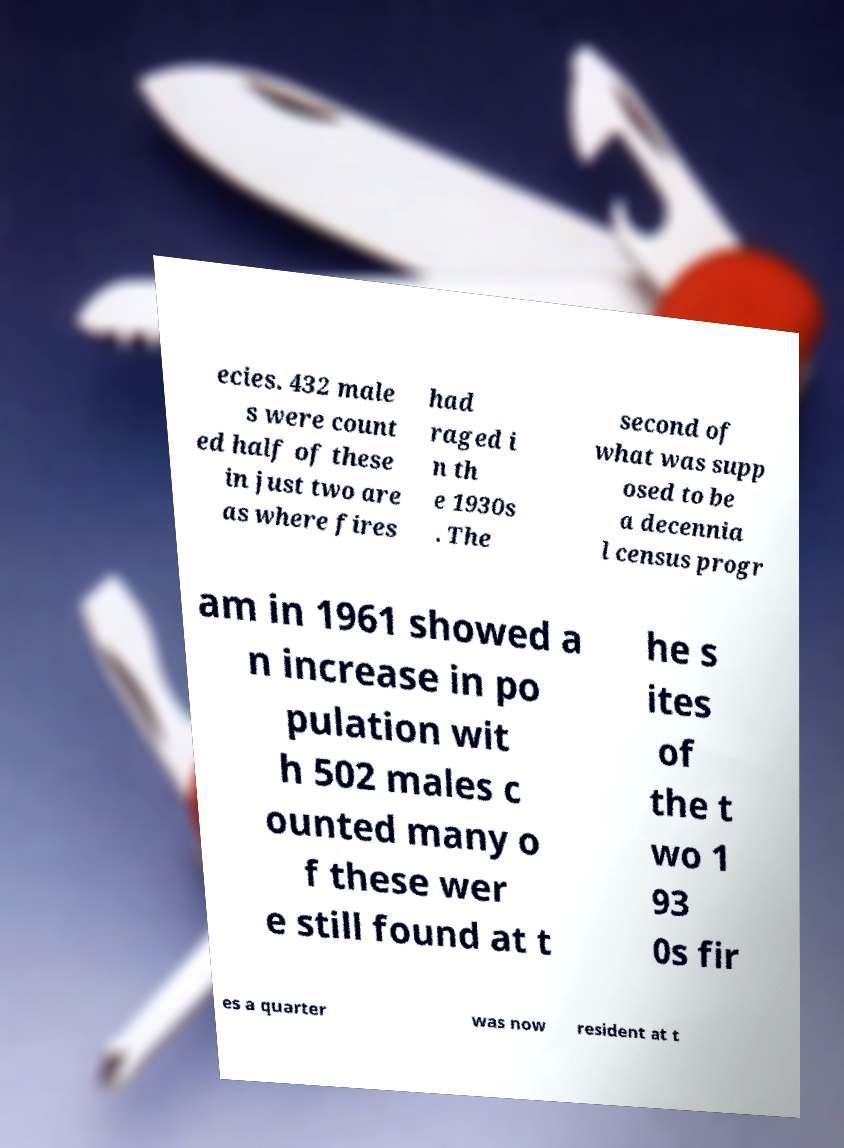Can you read and provide the text displayed in the image?This photo seems to have some interesting text. Can you extract and type it out for me? ecies. 432 male s were count ed half of these in just two are as where fires had raged i n th e 1930s . The second of what was supp osed to be a decennia l census progr am in 1961 showed a n increase in po pulation wit h 502 males c ounted many o f these wer e still found at t he s ites of the t wo 1 93 0s fir es a quarter was now resident at t 